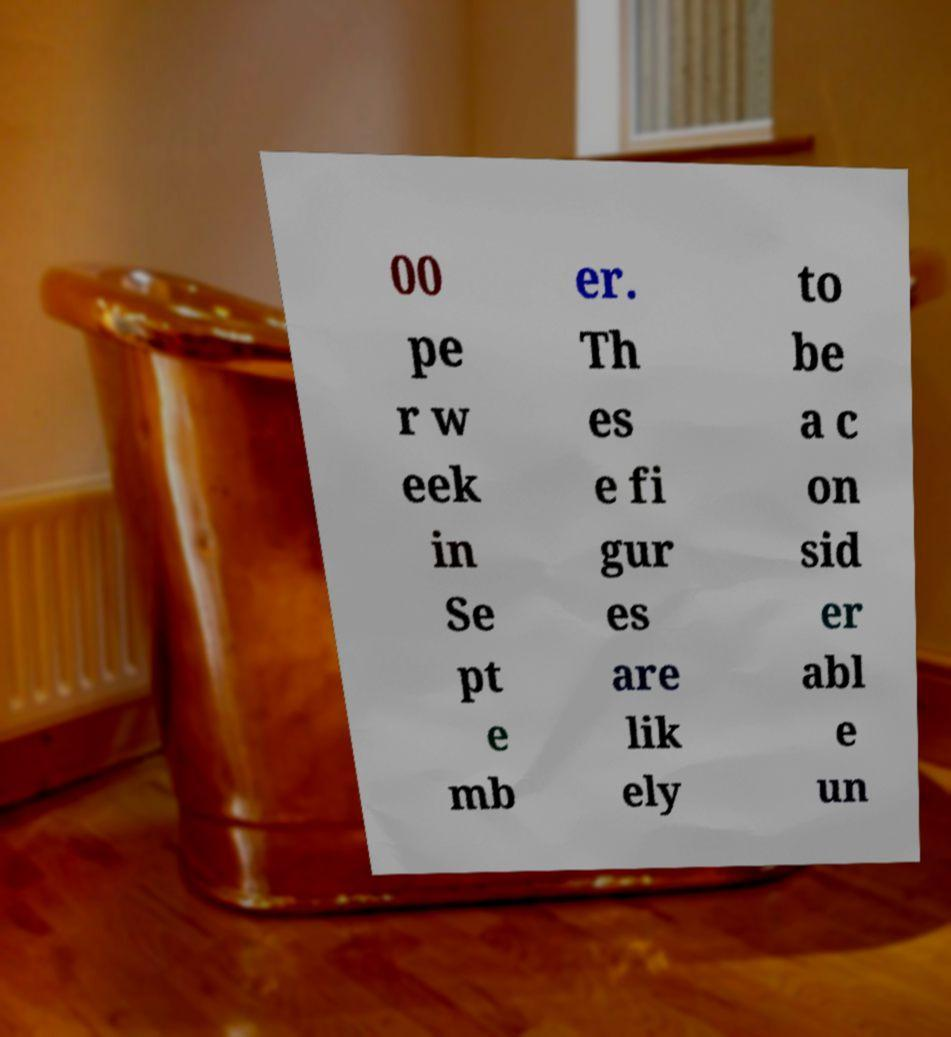I need the written content from this picture converted into text. Can you do that? 00 pe r w eek in Se pt e mb er. Th es e fi gur es are lik ely to be a c on sid er abl e un 